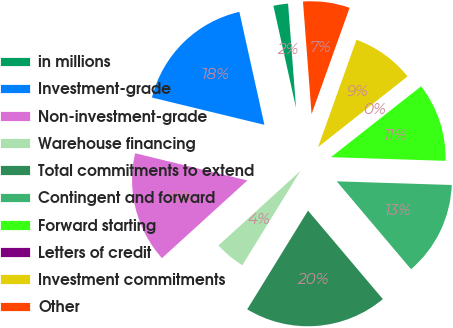Convert chart. <chart><loc_0><loc_0><loc_500><loc_500><pie_chart><fcel>in millions<fcel>Investment-grade<fcel>Non-investment-grade<fcel>Warehouse financing<fcel>Total commitments to extend<fcel>Contingent and forward<fcel>Forward starting<fcel>Letters of credit<fcel>Investment commitments<fcel>Other<nl><fcel>2.26%<fcel>17.74%<fcel>15.53%<fcel>4.47%<fcel>19.96%<fcel>13.32%<fcel>11.11%<fcel>0.04%<fcel>8.89%<fcel>6.68%<nl></chart> 